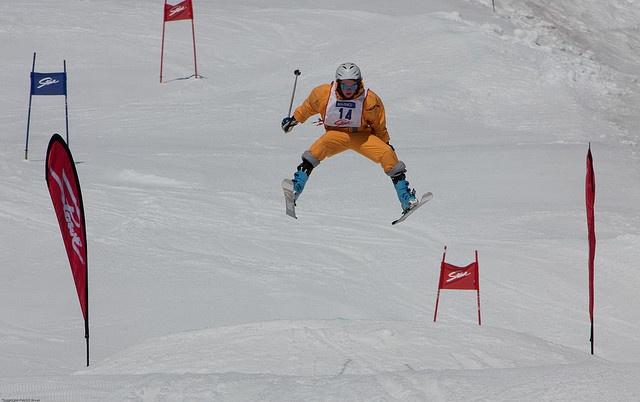Describe the objects in this image and their specific colors. I can see people in darkgray, brown, maroon, and black tones and skis in darkgray, gray, black, and lightgray tones in this image. 